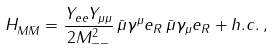<formula> <loc_0><loc_0><loc_500><loc_500>H _ { M \bar { M } } = \frac { Y _ { e e } Y _ { \mu \mu } } { 2 M _ { - - } ^ { 2 } } \, \bar { \mu } \gamma ^ { \mu } e _ { R } \, \bar { \mu } \gamma _ { \mu } e _ { R } + h . c . \, ,</formula> 